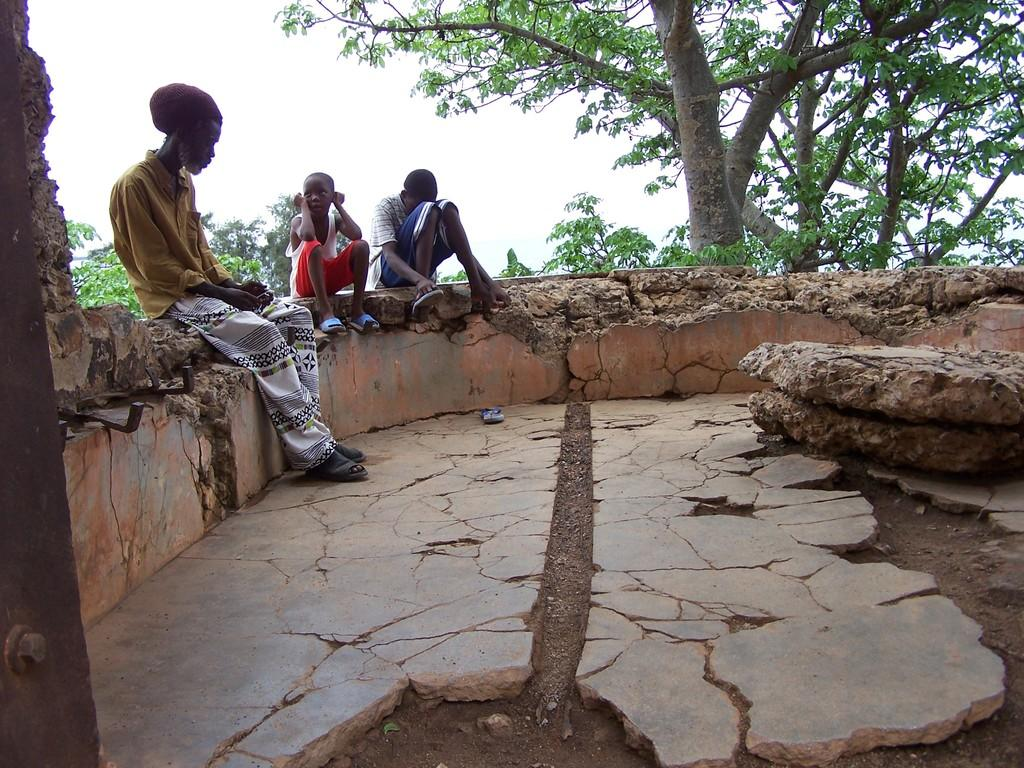Who is present in the image? There is a man and two boys in the image. What are they doing in the image? The man and boys are sitting on a fencing wall. What can be seen in the background of the image? There are trees and the sky visible in the background of the image. What is visible at the bottom of the image? The ground is visible in the image. What type of door can be seen in the image? There is no door present in the image; it features a man and two boys sitting on a fencing wall with trees and the sky in the background. What kind of yarn are the boys using to knit in the image? There is no yarn or knitting activity depicted in the image. 